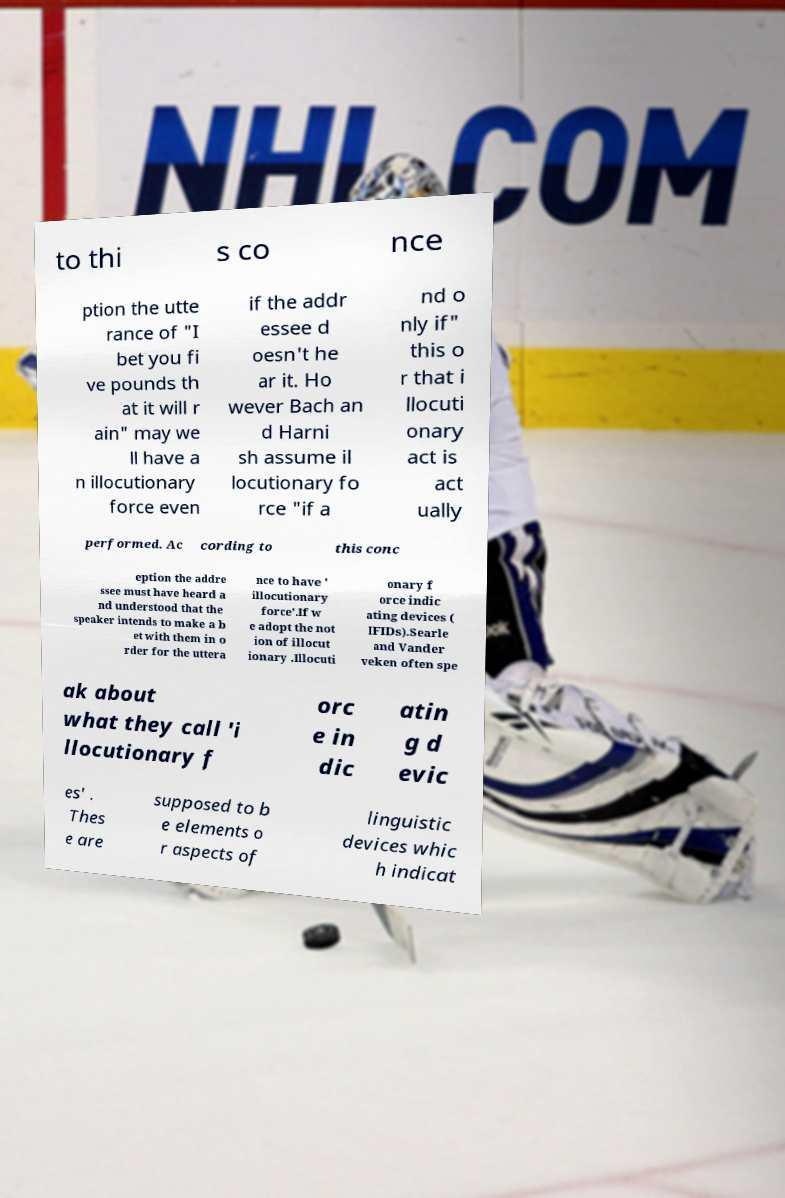There's text embedded in this image that I need extracted. Can you transcribe it verbatim? to thi s co nce ption the utte rance of "I bet you fi ve pounds th at it will r ain" may we ll have a n illocutionary force even if the addr essee d oesn't he ar it. Ho wever Bach an d Harni sh assume il locutionary fo rce "if a nd o nly if" this o r that i llocuti onary act is act ually performed. Ac cording to this conc eption the addre ssee must have heard a nd understood that the speaker intends to make a b et with them in o rder for the uttera nce to have ' illocutionary force'.If w e adopt the not ion of illocut ionary .Illocuti onary f orce indic ating devices ( IFIDs).Searle and Vander veken often spe ak about what they call 'i llocutionary f orc e in dic atin g d evic es' . Thes e are supposed to b e elements o r aspects of linguistic devices whic h indicat 